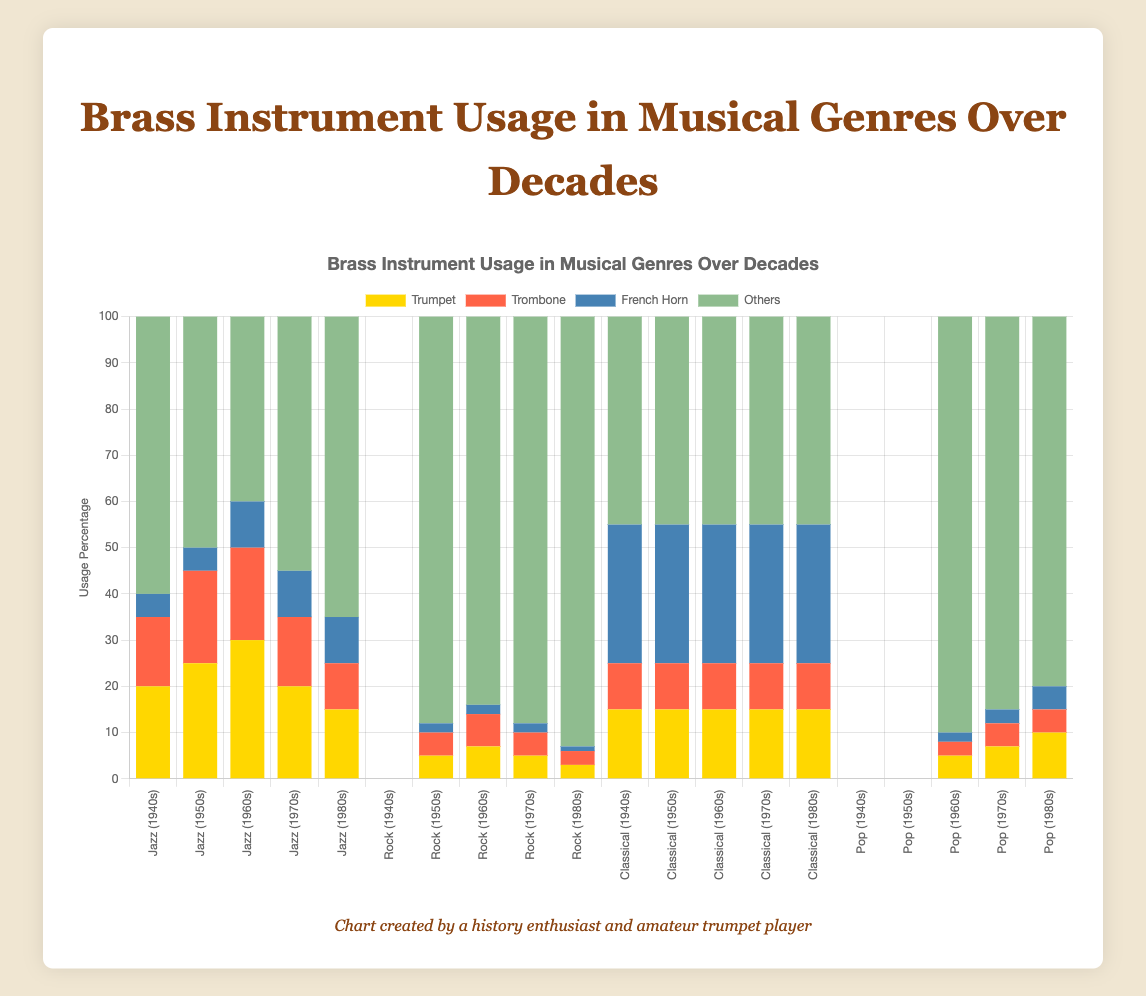Which genre has the highest percentage of trumpet usage in the 1960s? The genre with the highest trumpet usage in the 1960s can be determined by looking at the bars representing trumpet usage for each genre and summing the trumpet sections within the 1960s. Jazz has 30%, Rock has 7%, Classical has 15%, and Pop has 5%. Therefore, Jazz has the highest trumpet usage in the 1960s.
Answer: Jazz In which decade does Rock have the lowest brass instrument usage overall? To find the decade with the lowest brass instrument usage for Rock, one should sum the usages of trumpet, trombone, and French horn for each decade and compare them. For Rock, the percentages are: 1950s (5+5+2=12%), 1960s (7+7+2=16%), 1970s (5+5+2=12%), 1980s (3+3+1=7%). The lowest total is in the 1980s with 7%.
Answer: 1980s Compare the trumpet usage in Jazz from the 1940s to the 1980s. How does it change? Analyze the trumpet usage percentages for Jazz in each decade: 1940s (20%), 1950s (25%), 1960s (30%), 1970s (20%), 1980s (15%). From 1940s to 1950s, it increases by 5%, from 1950s to 1960s, it increases by 5% again. From 1960s to 1970s, it decreases by 10%, and from 1970s to 1980s, it decreases by 5%. Overall, from the 1940s to the 1980s, there is a net decrease of 5%.
Answer: Decreases by 5% What is the total percentage of French horn usage in Classical music across all decades shown? Sum up the French horn usage percentages for Classical music across each decade: 1940s (30%), 1950s (30%), 1960s (30%), 1970s (30%), 1980s (30%). Adding these gives 30 + 30 + 30 + 30 + 30 = 150%.
Answer: 150% Which decade sees a significant increase in trumpet usage for Pop compared to the previous decade? Compare the trumpet usage in Pop across the decades: 1960s (5%), 1970s (7%), 1980s (10%). From 1960s to 1970s, it increases by 2%, and from 1970s to 1980s, it increases by 3%. The significant increase (3%) occurs from the 1970s to the 1980s.
Answer: 1980s How does the trombone usage in Jazz change from the 1940s to the 1980s? Analyze the trombone usage percentages for Jazz in each decade: 1940s (15%), 1950s (20%), 1960s (20%), 1970s (15%), 1980s (10%). From the 1940s to 1950s, it increases by 5%, remains the same from the 1950s to the 1960s, decreases by 5% from the 1960s to the 1970s, and decreases by another 5% from the 1970s to the 1980s, resulting in a net decrease of 5%.
Answer: Decreases by 5% In the 1950s, which genre has the highest combined usage of brass instruments and what is the percentage? Sum the trumpet, trombone, and French horn usage for each genre in the 1950s: Jazz (25+20+5=50%), Rock (5+5+2=12%), Classical (15+10+30=55%). The highest combined usage is in Classical with 55%.
Answer: Classical (55%) What is the difference in other instrument usage for Rock between the 1970s and 1980s? The other instrument usage in Rock is 88% in the 1970s and 93% in the 1980s. The difference is 93 - 88 = 5%.
Answer: 5% Which brass instrument shows the most consistent usage in Classical music across decades and what is its usage percentage? For Classical music, compare the usage of each brass instrument across decades: Trumpet (15% consistently), Trombone (10% consistently), French Horn (30% consistently). All show consistent usage, but French Horn has the highest percentage at 30%.
Answer: French Horn (30%) Is the usage of French horn higher in Jazz or Pop in the 1970s? Compare French horn usage for Jazz and Pop in the 1970s: Jazz (10%), Pop (3%). The French horn usage is higher in Jazz.
Answer: Jazz 